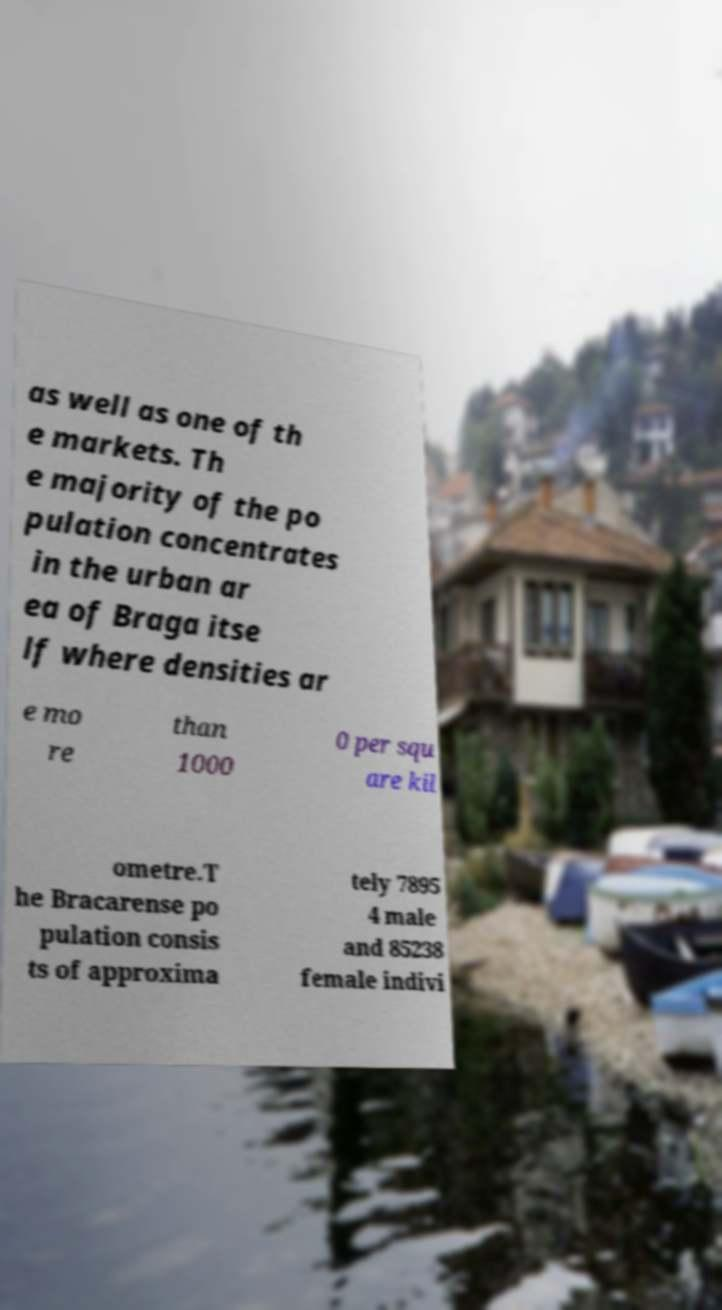Could you extract and type out the text from this image? as well as one of th e markets. Th e majority of the po pulation concentrates in the urban ar ea of Braga itse lf where densities ar e mo re than 1000 0 per squ are kil ometre.T he Bracarense po pulation consis ts of approxima tely 7895 4 male and 85238 female indivi 